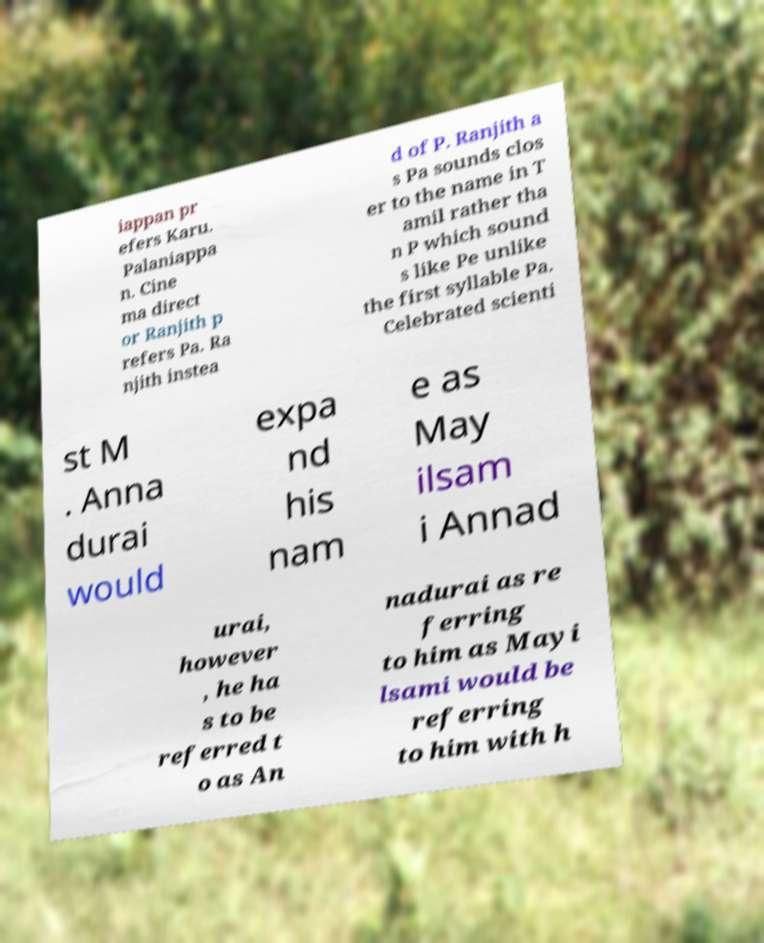I need the written content from this picture converted into text. Can you do that? iappan pr efers Karu. Palaniappa n. Cine ma direct or Ranjith p refers Pa. Ra njith instea d of P. Ranjith a s Pa sounds clos er to the name in T amil rather tha n P which sound s like Pe unlike the first syllable Pa. Celebrated scienti st M . Anna durai would expa nd his nam e as May ilsam i Annad urai, however , he ha s to be referred t o as An nadurai as re ferring to him as Mayi lsami would be referring to him with h 